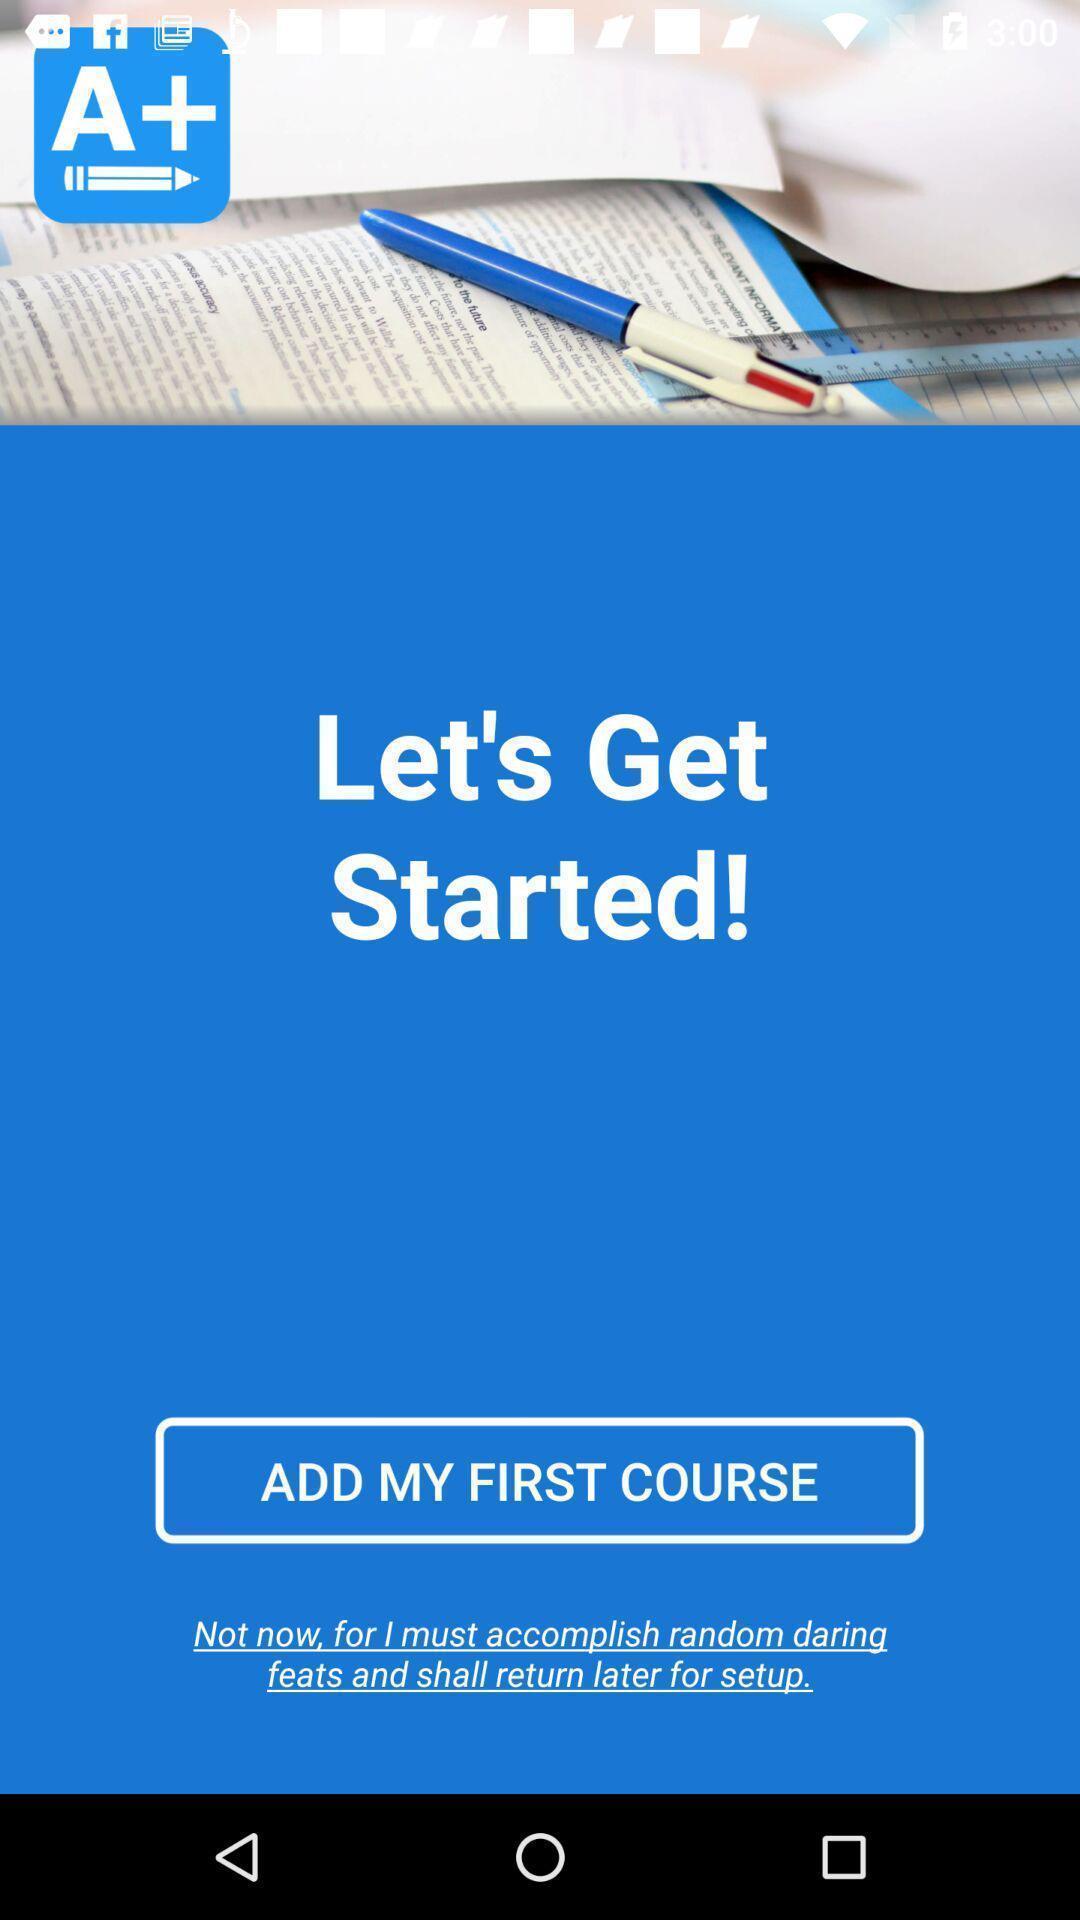Give me a summary of this screen capture. Window displaying a grade tracker app. 